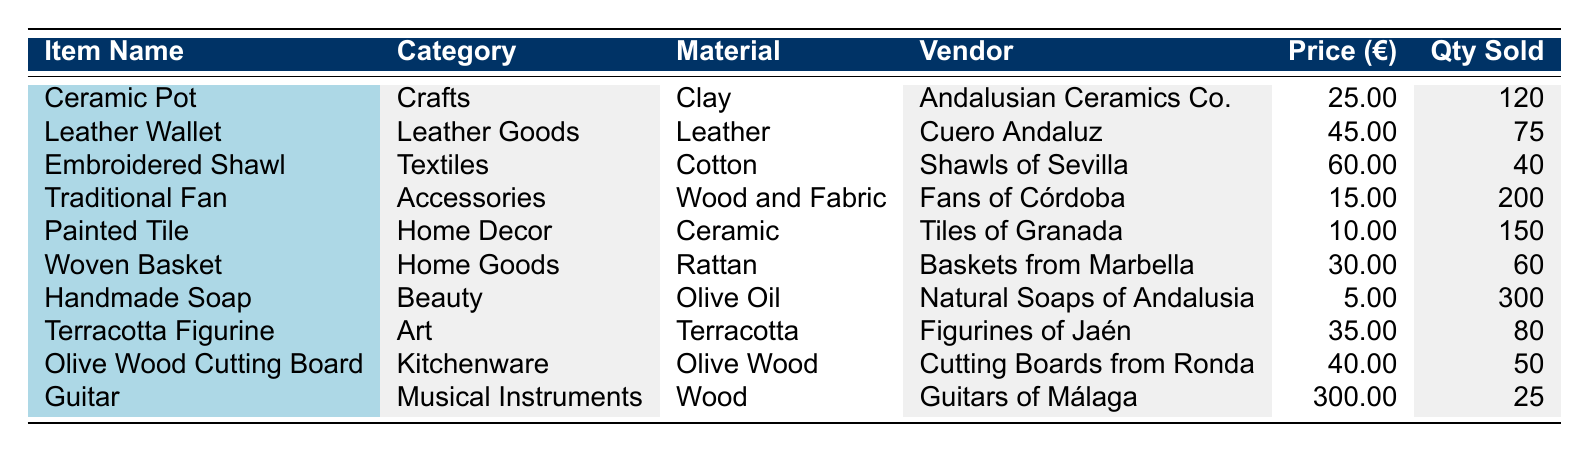What is the total revenue generated from the sale of the Ceramic Pot? The total revenue for the Ceramic Pot is specifically listed in the table under the "Total Revenue" column. It is indicated as 3000.00.
Answer: 3000.00 Which item had the highest price in 2023? By examining the "Price" column, the Guitar has the highest price at 300.00 compared to the other items in the table.
Answer: Guitar How many more Painted Tiles were sold than Traditional Fans? The quantity sold for Painted Tiles is 150, and for Traditional Fans, it is 200. Thus, we compute the difference: 150 - 200 = -50, indicating that 50 fewer Painted Tiles were sold.
Answer: 50 fewer Was the total revenue from Handmade Soaps greater than 2000.00? The total revenue for Handmade Soaps is listed as 1500.00 in the table. Since 1500.00 is less than 2000.00, the answer is no.
Answer: No What is the average price of items sold? To find the average price, we first sum all the prices: (25 + 45 + 60 + 15 + 10 + 30 + 5 + 35 + 40 + 300) = 620. There are 10 items, so we calculate the average: 620 / 10 = 62.0.
Answer: 62.0 Which vendor sold the most items, and how many? We check the "Qty Sold" for each vendor. The Handmade Soap from Natural Soaps of Andalusia sold the most, which is 300 units.
Answer: Natural Soaps of Andalusia, 300 Is the material of the Olive Wood Cutting Board Olive Wood? The table lists the material for the Olive Wood Cutting Board under the "Material" column as Olive Wood, confirming that the statement is true.
Answer: Yes How many total items were sold across all categories? We sum the "Qty Sold" for each item: (120 + 75 + 40 + 200 + 150 + 60 + 300 + 80 + 50 + 25) = 1100 total items sold.
Answer: 1100 If we combine the revenues from Ceramic Pots and Terracotta Figurines, what is the total? The total revenue from Ceramic Pots is 3000.00, and from Terracotta Figurines it is 2800.00. Adding both: 3000 + 2800 = 5800.
Answer: 5800 